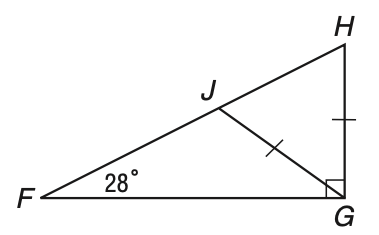Question: In the figure, \triangle F G H is a right triangle with hypotenuse F H and G J = G H. What is the measure of \angle J G H?
Choices:
A. 28
B. 56
C. 62
D. 104
Answer with the letter. Answer: B 